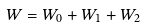Convert formula to latex. <formula><loc_0><loc_0><loc_500><loc_500>W = W _ { 0 } + W _ { 1 } + W _ { 2 }</formula> 